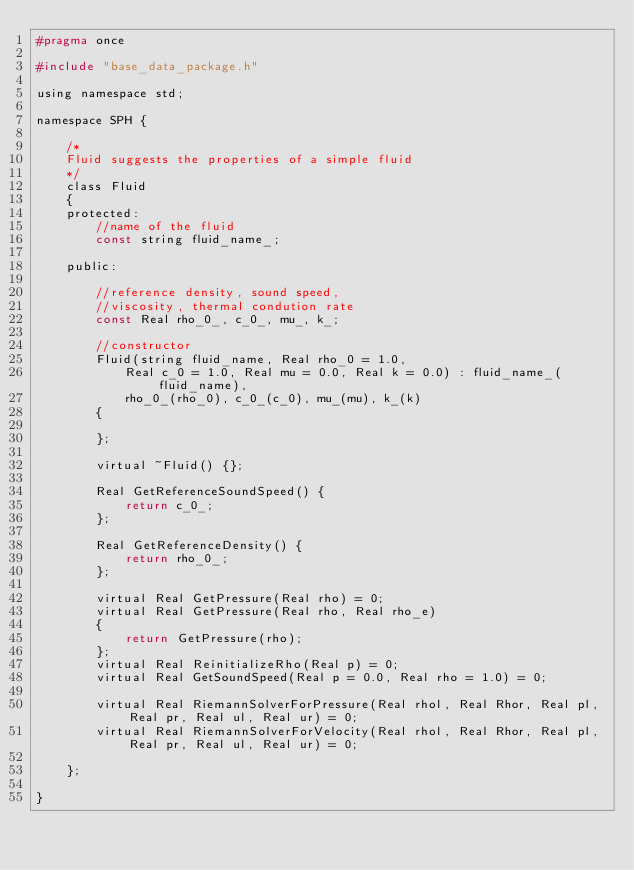<code> <loc_0><loc_0><loc_500><loc_500><_C_>#pragma once

#include "base_data_package.h"

using namespace std;

namespace SPH {

	/*
	Fluid suggests the properties of a simple fluid
	*/
	class Fluid
	{
	protected:
		//name of the fluid
		const string fluid_name_;

	public:

		//reference density, sound speed, 
		//viscosity, thermal condution rate
		const Real rho_0_, c_0_, mu_, k_;

		//constructor
		Fluid(string fluid_name, Real rho_0 = 1.0, 
			Real c_0 = 1.0, Real mu = 0.0, Real k = 0.0) : fluid_name_(fluid_name),
			rho_0_(rho_0), c_0_(c_0), mu_(mu), k_(k)
		{

		};

		virtual ~Fluid() {};

		Real GetReferenceSoundSpeed() {
			return c_0_;
		};

		Real GetReferenceDensity() {
			return rho_0_;
		};

		virtual Real GetPressure(Real rho) = 0;
		virtual Real GetPressure(Real rho, Real rho_e)
		{
			return GetPressure(rho);
		};
		virtual Real ReinitializeRho(Real p) = 0;
		virtual Real GetSoundSpeed(Real p = 0.0, Real rho = 1.0) = 0;

		virtual Real RiemannSolverForPressure(Real rhol, Real Rhor, Real pl, Real pr, Real ul, Real ur) = 0;
		virtual Real RiemannSolverForVelocity(Real rhol, Real Rhor, Real pl, Real pr, Real ul, Real ur) = 0;

	};

}</code> 